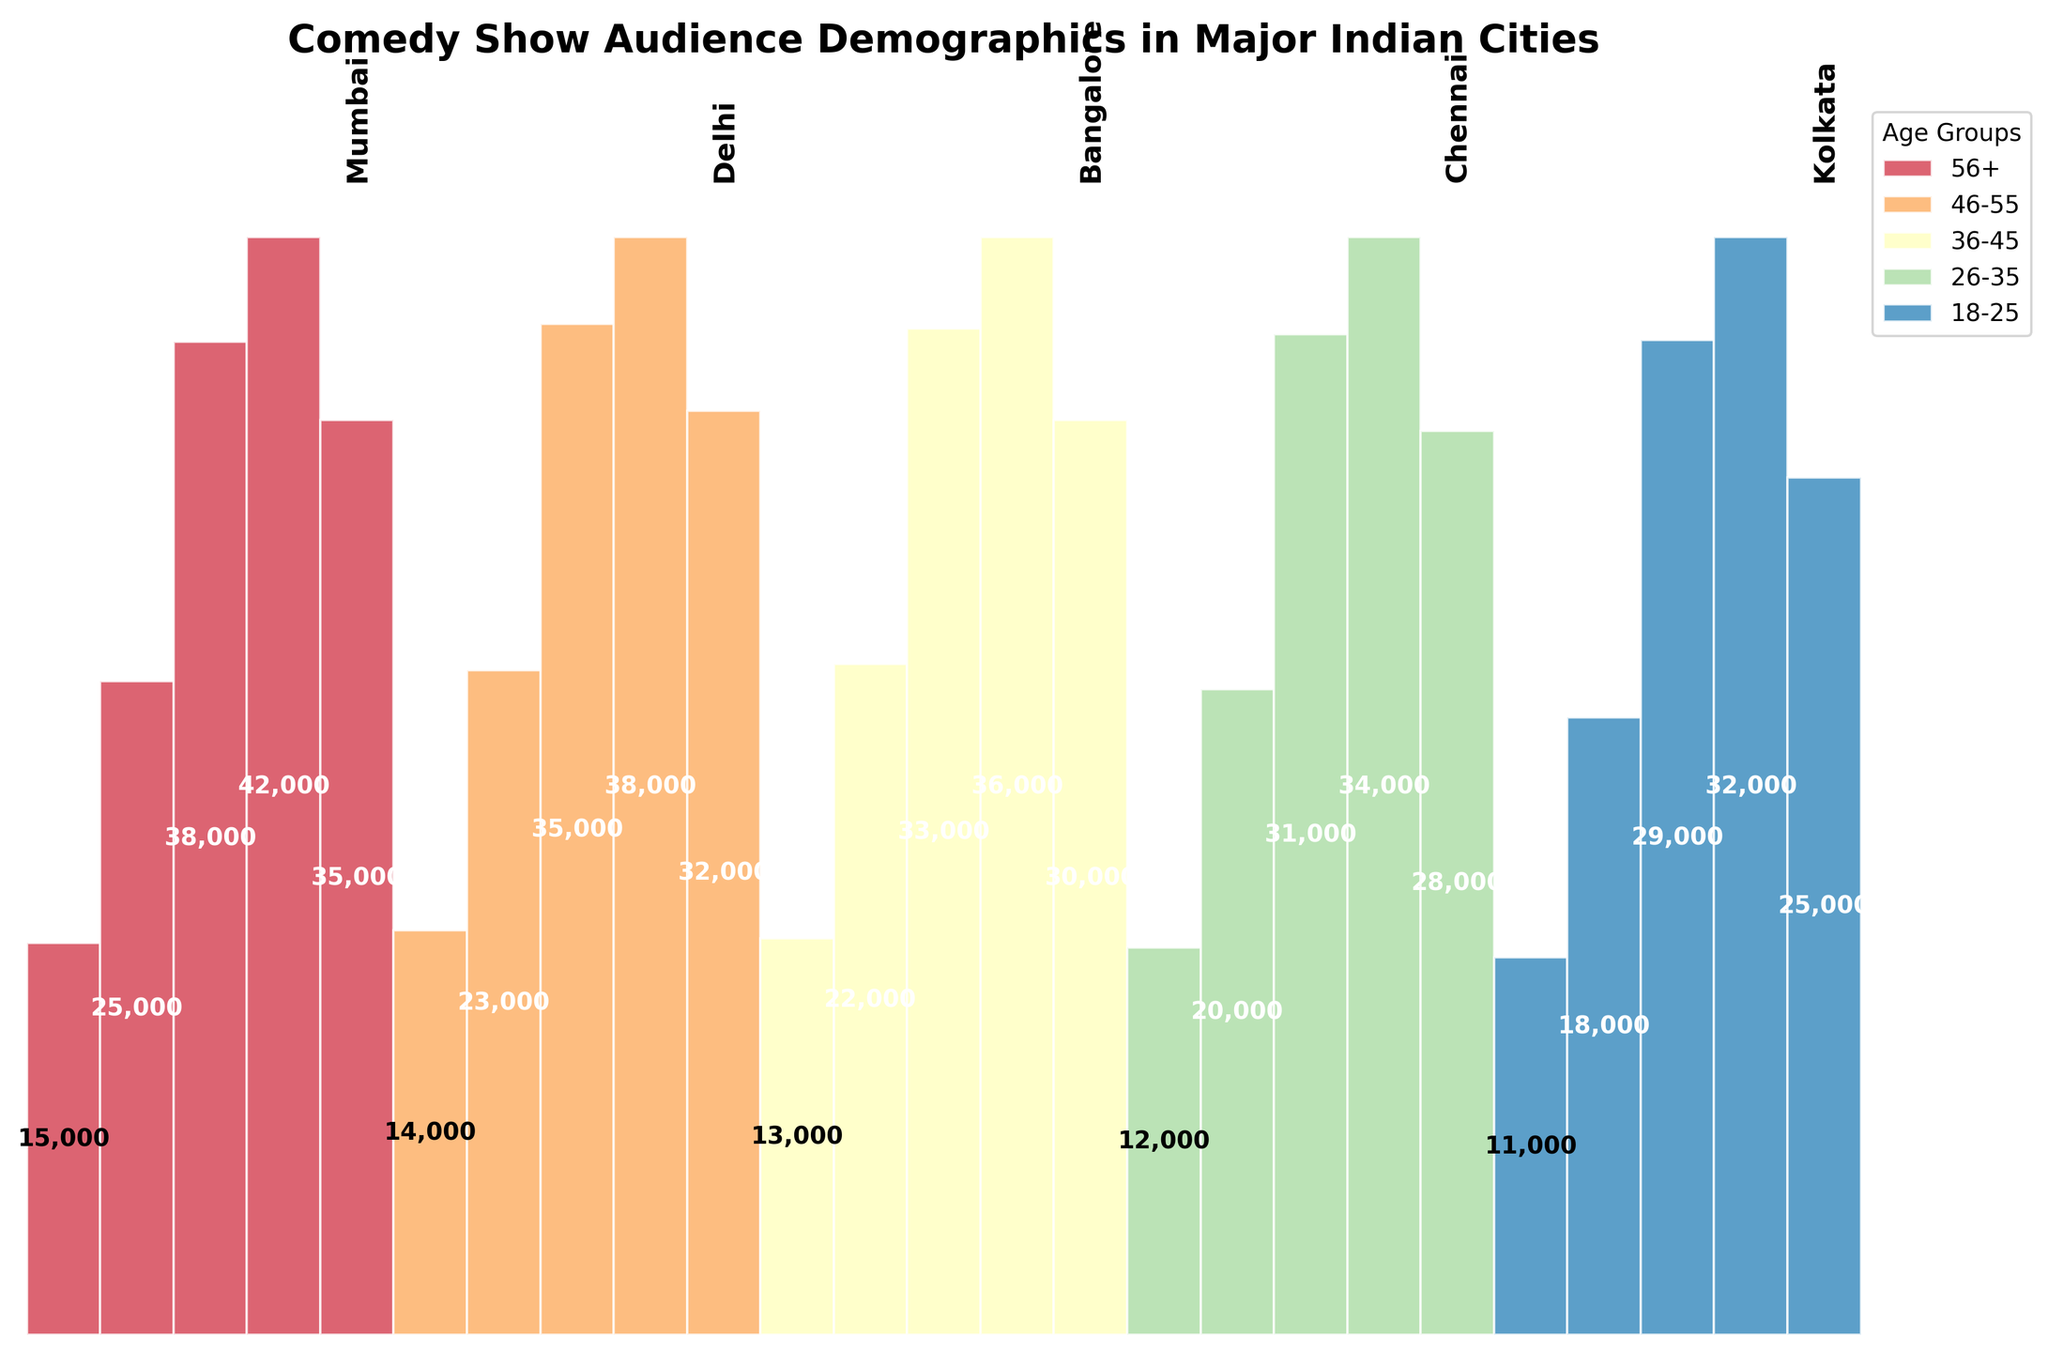How many age groups are displayed in the chart? The title and legend of the chart show the demographic breakdown of the audience, and the legend indicates the number of age groups.
Answer: Five Which city has the highest audience count in the 26-35 age group? Observing the funnel sections, the width of the section for each city represents the audience count, and the city with the widest section in the 26-35 age group will have the highest count.
Answer: Mumbai What is the total audience count in Delhi across all age groups? Add the audience counts for each age group in Delhi: 32,000 (18-25) + 38,000 (26-35) + 35,000 (36-45) + 23,000 (46-55) + 14,000 (56+).
Answer: 142,000 Which city has the smallest audience count in the 56+ age group? Look at the widths of the funnel sections for each city in the 56+ age group; the narrowest section represents the smallest count.
Answer: Kolkata How does the audience size in the 18-25 age group in Bangalore compare to that in Chennai? Compare the widths of the funnel sections for Bangalore and Chennai in the 18-25 age group; slightly wider width indicates a larger audience.
Answer: Bangalore is larger Is the audience size in the 26-35 age group larger in Mumbai or Bangalore? Compare the funnel section widths for the 26-35 age group in Mumbai and Bangalore; the wider section corresponds to a larger audience size.
Answer: Mumbai Which city has the second highest audience count in the 36-45 age group? Identify the widths of the funnel sections in the 36-45 age group and find the second widest section.
Answer: Delhi What is the percentage difference in audience size between the 46-55 and 56+ age groups in Kolkata? First, find the audience counts: 18,000 (46-55) and 11,000 (56+). Then, calculate the difference: 18,000 - 11,000 = 7,000. Finally, the percentage difference relative to 56+ group: (7,000 / 11,000) * 100%.
Answer: 63.64% In which age group does Chennai have the lowest audience count? Examine the funnel section widths for Chennai across all age groups; the narrowest section indicates the lowest count.
Answer: 56+ Can you determine the most popular age group overall based on the chart? The overall popular age group can be determined by observing which age group consistently has the widest sections in most cities.
Answer: 26-35 